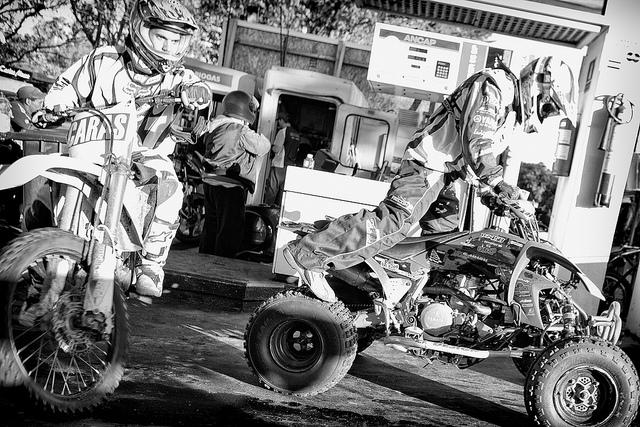What is the man on the right riding?

Choices:
A) scooter
B) quad
C) bicycle
D) motorcycle quad 